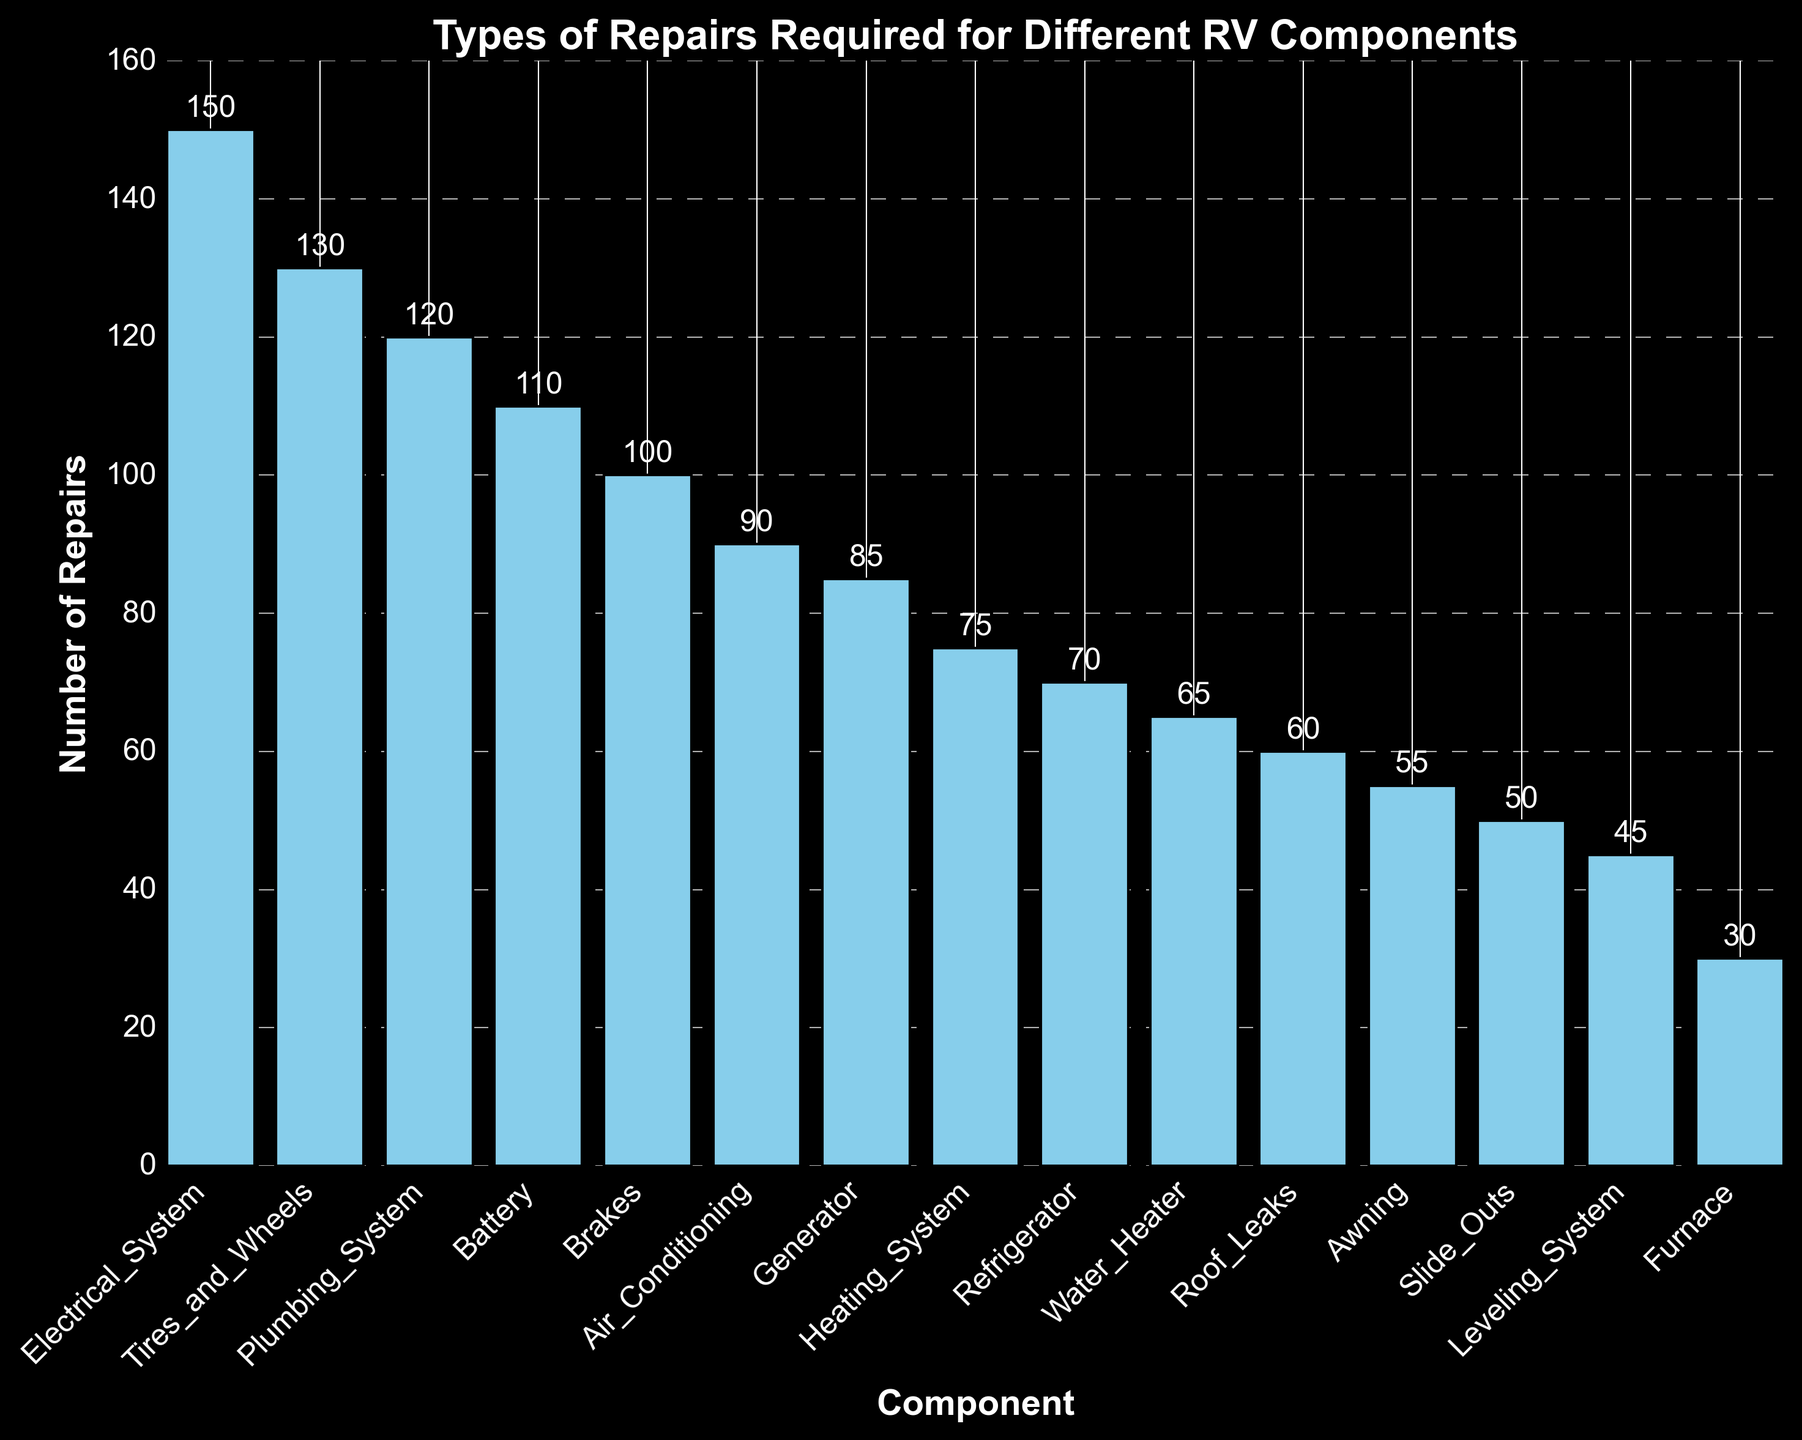What component requires the highest number of repairs? The component with the highest number of repairs will have the tallest bar in the chart. The electrical system shows the tallest bar.
Answer: Electrical System Which has more repairs, the tires and wheels or the brakes? Compare the height of the bars representing tires and wheels and brakes. The bar for tires and wheels is taller than the bar for brakes.
Answer: Tires and Wheels What is the combined total of repairs for the plumbing system and the refrigerator? Add the number of repairs for the plumbing system (120) and the refrigerator (70). So, 120 + 70 = 190.
Answer: 190 Are there more repairs for the generator or for the air conditioning system? Compare the height of the bars representing the generator and the air conditioning system. The generator bar is taller.
Answer: Generator What is the smallest number of repairs required by any component, and which component is it? Look for the shortest bar in the chart. The furnace has the shortest bar, showing 30 repairs.
Answer: 30, Furnace How many more repairs are needed for the electrical system compared to the heating system? Subtract the number of repairs for the heating system (75) from the number of repairs for the electrical system (150). So, 150 - 75 = 75.
Answer: 75 Which three components have the fewest repairs? Identify the three shortest bars in the chart. The furnace, leveling system, and slide outs have the shortest bars.
Answer: Furnace, Leveling System, Slide Outs What is the total number of repairs for components that have more than 100 repairs each? Identify components with more than 100 repairs and sum their repairs: Electrical System (150), Tires and Wheels (130), and Battery (110). So, 150 + 130 + 110 = 390.
Answer: 390 Between the roof leaks and the water heater, which has fewer repairs and by how much? Compare the heights of the bars for roof leaks and water heater. Roof leaks have 60 repairs, and the water heater has 65. The difference is 65 - 60 = 5.
Answer: Roof Leaks, 5 What is the average number of repairs for the air conditioning, refrigerator, and awning components? Sum the number of repairs for air conditioning (90), refrigerator (70), and awning (55), then divide by 3. So, (90 + 70 + 55) / 3 = 215 / 3 ≈ 71.67.
Answer: 71.67 